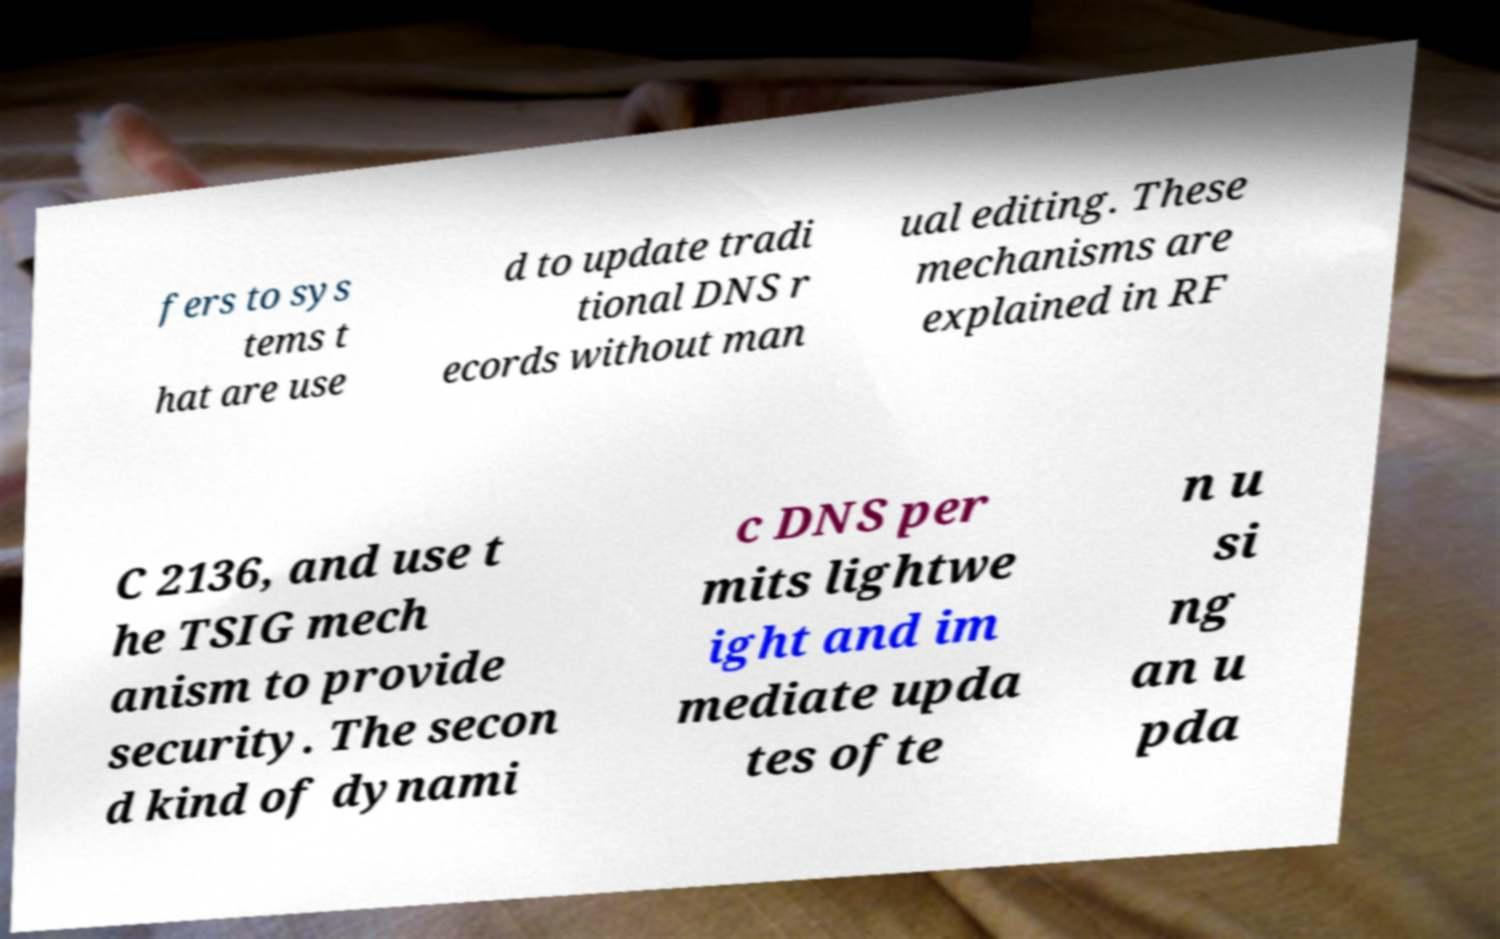Could you extract and type out the text from this image? fers to sys tems t hat are use d to update tradi tional DNS r ecords without man ual editing. These mechanisms are explained in RF C 2136, and use t he TSIG mech anism to provide security. The secon d kind of dynami c DNS per mits lightwe ight and im mediate upda tes ofte n u si ng an u pda 